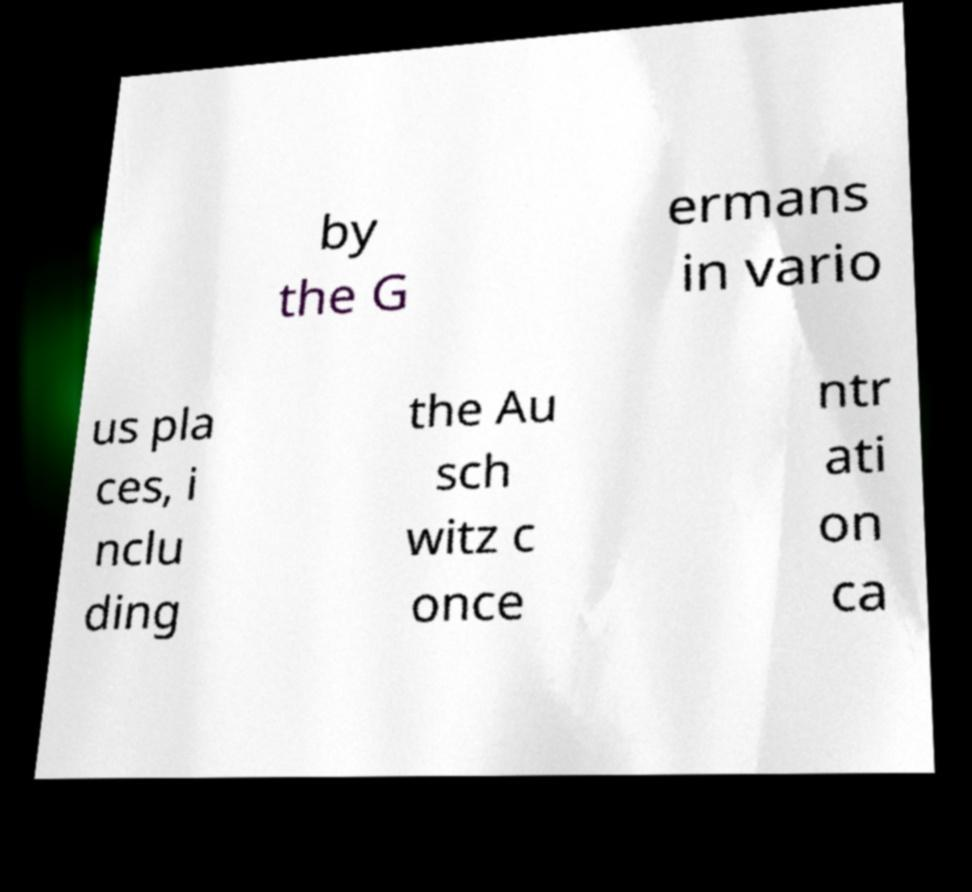For documentation purposes, I need the text within this image transcribed. Could you provide that? by the G ermans in vario us pla ces, i nclu ding the Au sch witz c once ntr ati on ca 